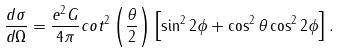<formula> <loc_0><loc_0><loc_500><loc_500>\frac { d \sigma } { d \Omega } = \frac { e ^ { 2 } G } { 4 \pi } c o t ^ { 2 } \left ( \frac { \theta } { 2 } \right ) \left [ \sin ^ { 2 } 2 \phi + \cos ^ { 2 } \theta \cos ^ { 2 } 2 \phi \right ] .</formula> 